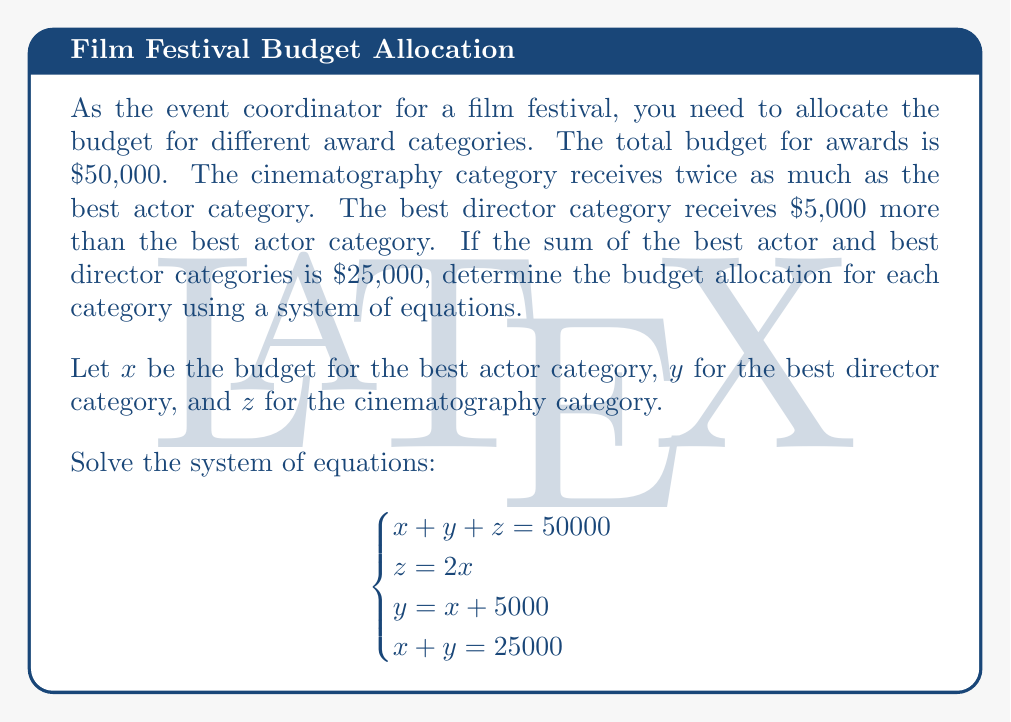Solve this math problem. Let's solve this system of equations step by step:

1) From the third equation: $y = x + 5000$

2) Substitute this into the fourth equation:
   $x + (x + 5000) = 25000$
   $2x + 5000 = 25000$
   $2x = 20000$
   $x = 10000$

3) Now we know $x = 10000$, we can find $y$:
   $y = x + 5000 = 10000 + 5000 = 15000$

4) From the second equation:
   $z = 2x = 2(10000) = 20000$

5) Let's verify using the first equation:
   $x + y + z = 10000 + 15000 + 20000 = 45000$

Therefore, the budget allocations are:
Best Actor (x): $10,000
Best Director (y): $15,000
Cinematography (z): $20,000

The total is indeed $45,000, which matches the given total budget of $50,000.
Answer: Best Actor: $10,000; Best Director: $15,000; Cinematography: $20,000 